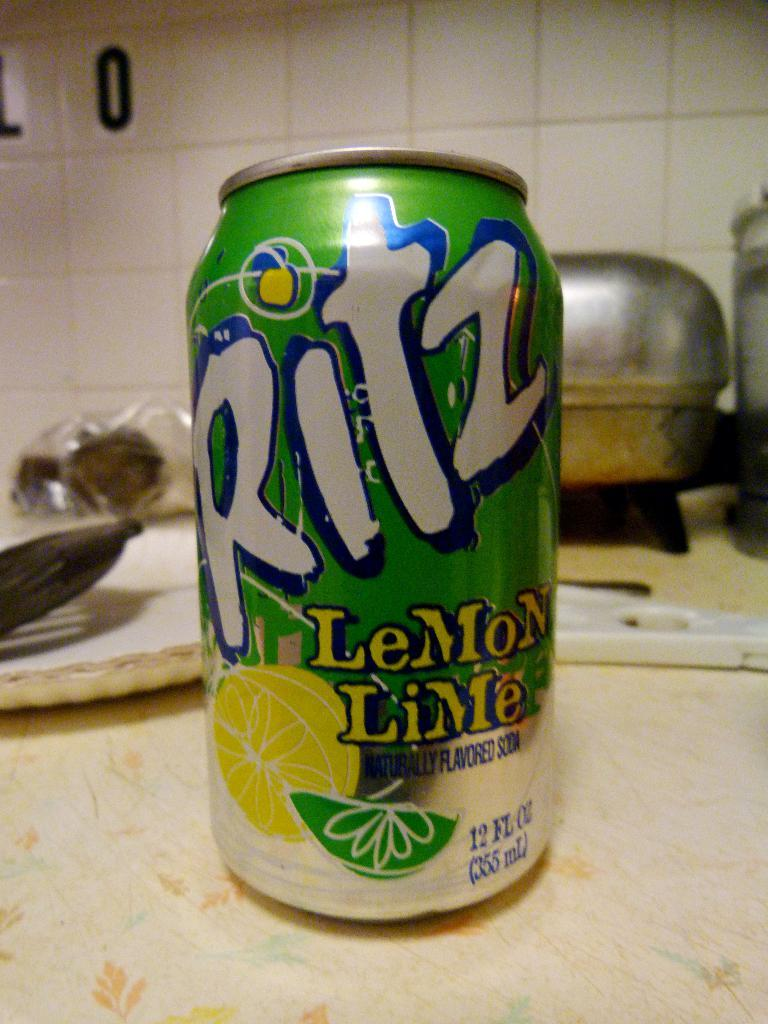Provide a one-sentence caption for the provided image. a ritz can that is on a light surface. 